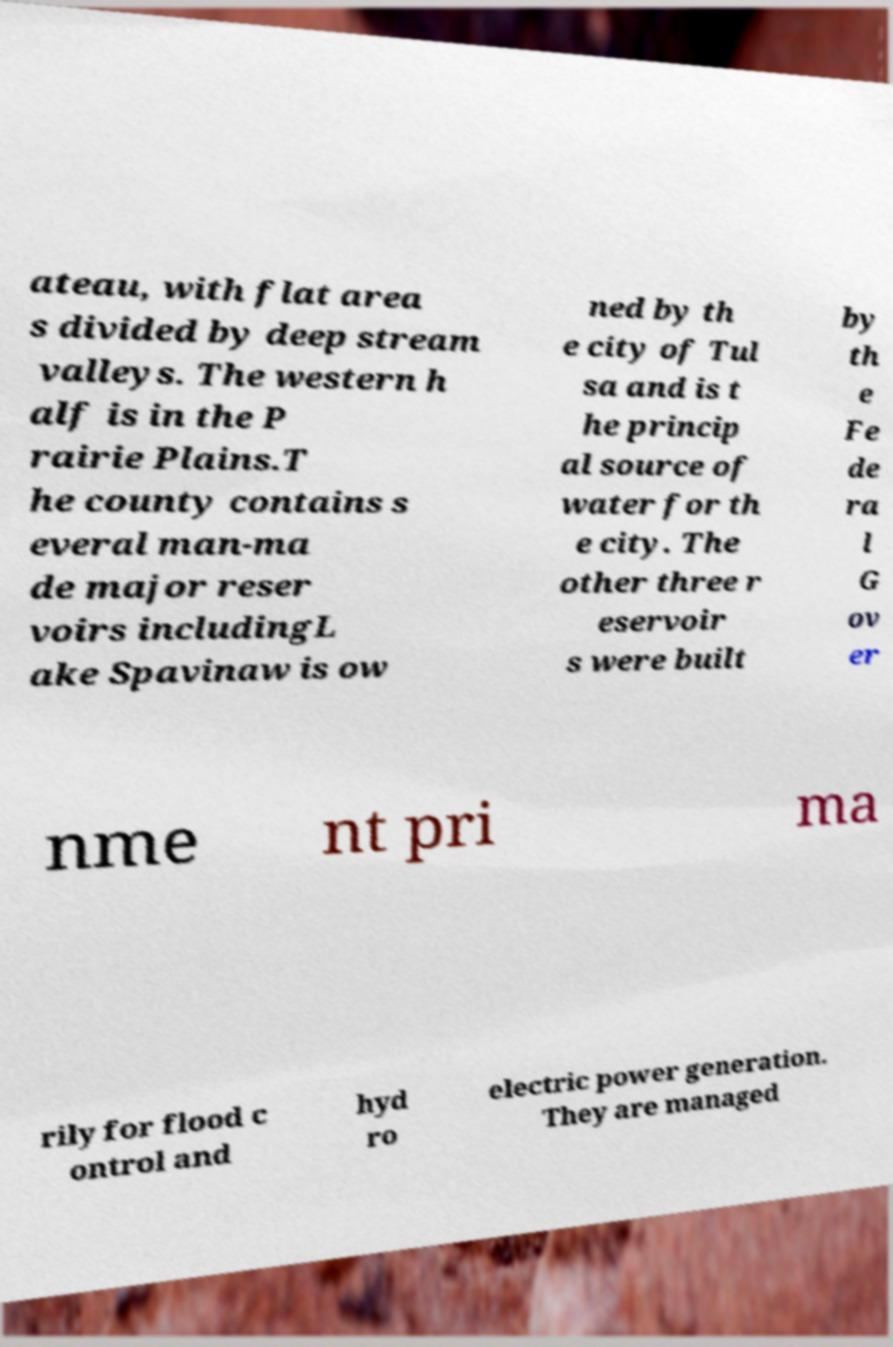Can you read and provide the text displayed in the image?This photo seems to have some interesting text. Can you extract and type it out for me? ateau, with flat area s divided by deep stream valleys. The western h alf is in the P rairie Plains.T he county contains s everal man-ma de major reser voirs includingL ake Spavinaw is ow ned by th e city of Tul sa and is t he princip al source of water for th e city. The other three r eservoir s were built by th e Fe de ra l G ov er nme nt pri ma rily for flood c ontrol and hyd ro electric power generation. They are managed 